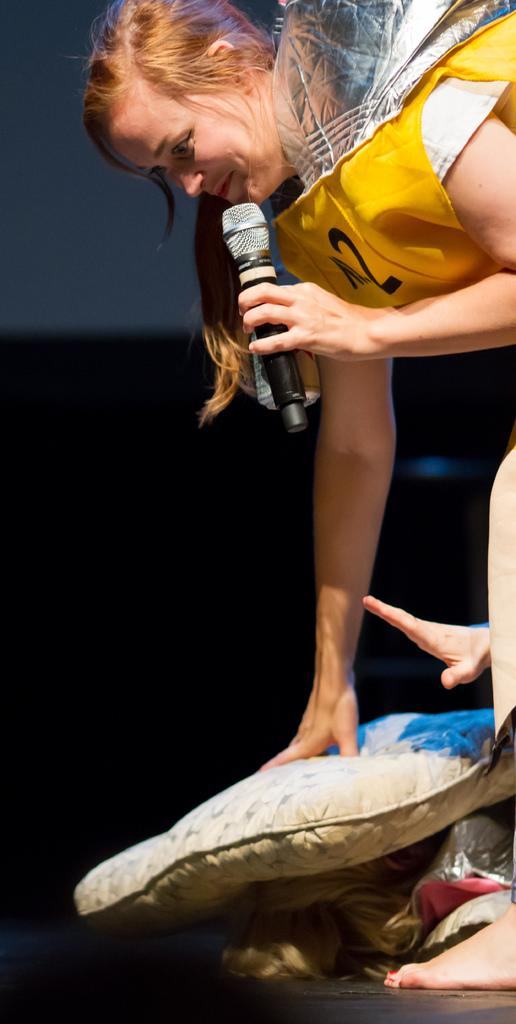What is the woman in the image wearing? The woman is wearing a yellow jacket. What is the woman holding in the image? The woman is holding a microphone. What expression does the woman have in the image? The woman is smiling. What is the woman doing with the pillow in the image? The woman is placing a pillow on another woman's head. What type of knowledge can be seen in the image? There is no knowledge visible in the image; it features a woman wearing a yellow jacket, holding a microphone, smiling, and placing a pillow on another woman's head. 